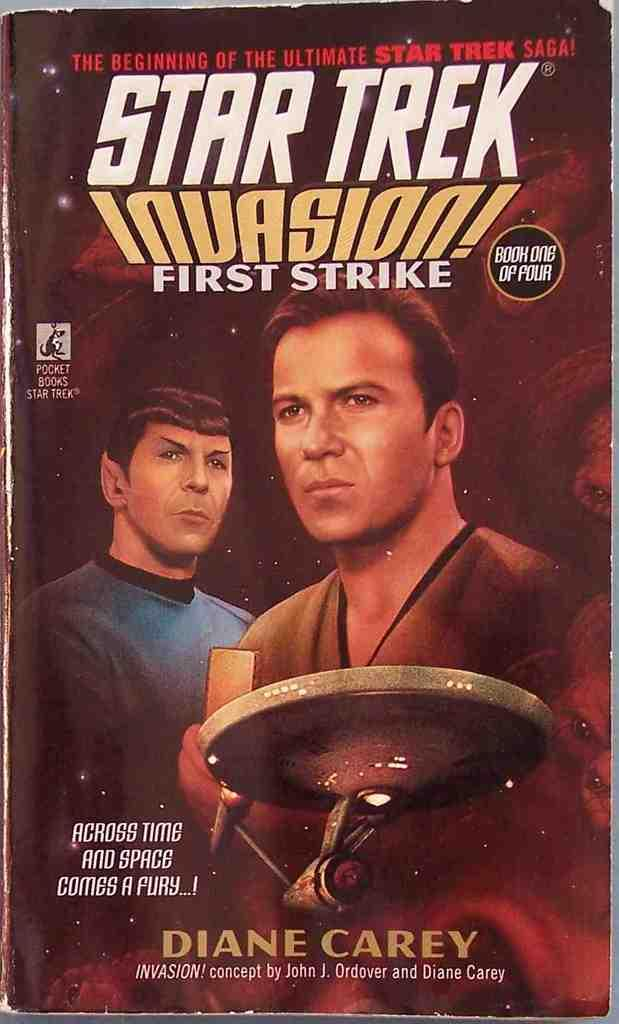Provide a one-sentence caption for the provided image. Star Trek Invasion first strike saga by Diane Carey. 